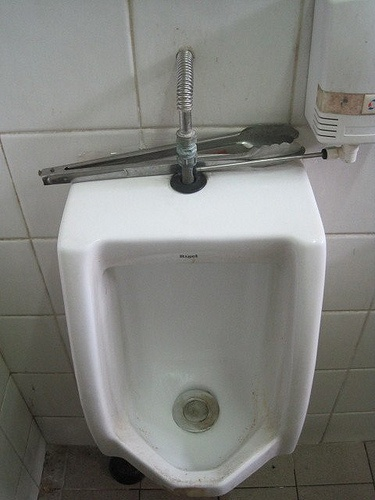Describe the objects in this image and their specific colors. I can see a toilet in gray, darkgray, and lightgray tones in this image. 